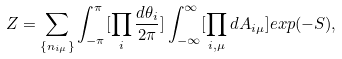<formula> <loc_0><loc_0><loc_500><loc_500>Z = \sum _ { \{ n _ { i \mu } \} } \int _ { - \pi } ^ { \pi } [ \prod _ { i } \frac { d \theta _ { i } } { 2 \pi } ] \int _ { - \infty } ^ { \infty } [ \prod _ { i , \mu } d A _ { i \mu } ] e x p ( - S ) ,</formula> 